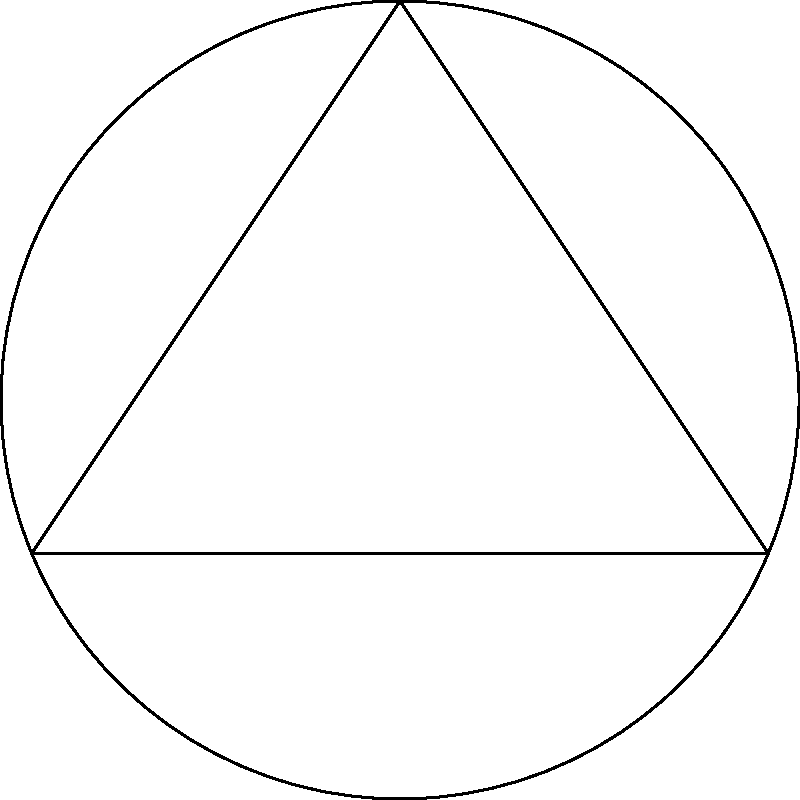In the diagram, a cultural circle is represented by the circle ABC, with tangent lines drawn from external points D and E. These tangent lines symbolize the intersection of cultural influences with political borders. If the angle between the two tangent lines is 60°, what is the measure of angle ACB in the cultural circle? To solve this problem, we'll use the properties of tangents and inscribed angles in a circle:

1. In a circle, the angle between a tangent and a chord at the point of contact is equal to the angle in the alternate segment.

2. The angle between two tangents drawn from an external point to a circle is twice the angle subtended at the center by the two points of contact.

3. The inscribed angle theorem states that an angle inscribed in a circle is half the central angle subtending the same arc.

4. Given that the angle between the tangent lines is 60°, the central angle subtended by the arc AB is 120° (twice the angle between tangents).

5. Angle ACB is an inscribed angle that subtends the same arc AB.

6. By the inscribed angle theorem, angle ACB is half of the central angle.

7. Therefore, angle ACB = 120° / 2 = 60°

This geometric relationship can be interpreted as how the intensity of cultural influence (represented by the inscribed angle) relates to the interaction with political borders (represented by the angle between tangents).
Answer: 60° 